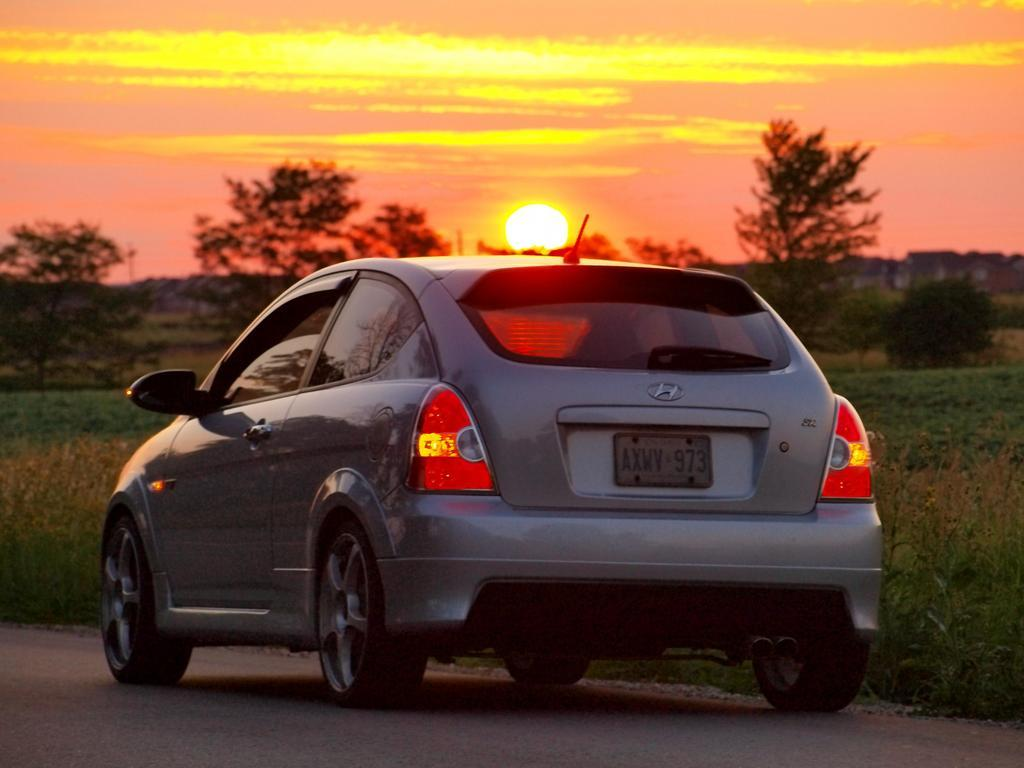What is the main subject of the image? There is a car on the road in the image. What can be seen behind the car? There is grassy land behind the car. What type of vegetation is present in the grassy land? Plants and trees are visible in the grassy land. What is visible in the sky in the background of the image? The sun is observable in the sky in the background of the image. Where is the band playing in the image? There is no band present in the image. What type of angle is the car positioned at in the image? The image does not provide information about the angle at which the car is positioned. 